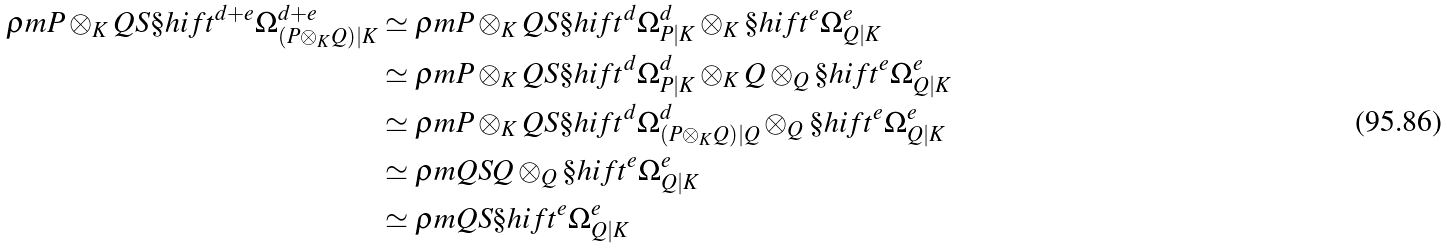<formula> <loc_0><loc_0><loc_500><loc_500>\rho m { P \otimes _ { K } Q } S { \S h i f t ^ { d + e } \Omega ^ { d + e } _ { ( P \otimes _ { K } Q ) | K } } & \simeq \rho m { P \otimes _ { K } Q } S { \S h i f t ^ { d } \Omega ^ { d } _ { P | K } \otimes _ { K } \S h i f t ^ { e } \Omega ^ { e } _ { Q | K } } \\ & \simeq \rho m { P \otimes _ { K } Q } S { \S h i f t ^ { d } \Omega ^ { d } _ { P | K } \otimes _ { K } Q } \otimes _ { Q } \S h i f t ^ { e } \Omega ^ { e } _ { Q | K } \\ & \simeq \rho m { P \otimes _ { K } Q } S { \S h i f t ^ { d } \Omega ^ { d } _ { ( P \otimes _ { K } Q ) | Q } } \otimes _ { Q } \S h i f t ^ { e } \Omega ^ { e } _ { Q | K } \\ & \simeq \rho m Q S Q \otimes _ { Q } \S h i f t ^ { e } \Omega ^ { e } _ { Q | K } \\ & \simeq \rho m Q S { \S h i f t ^ { e } \Omega ^ { e } _ { Q | K } }</formula> 